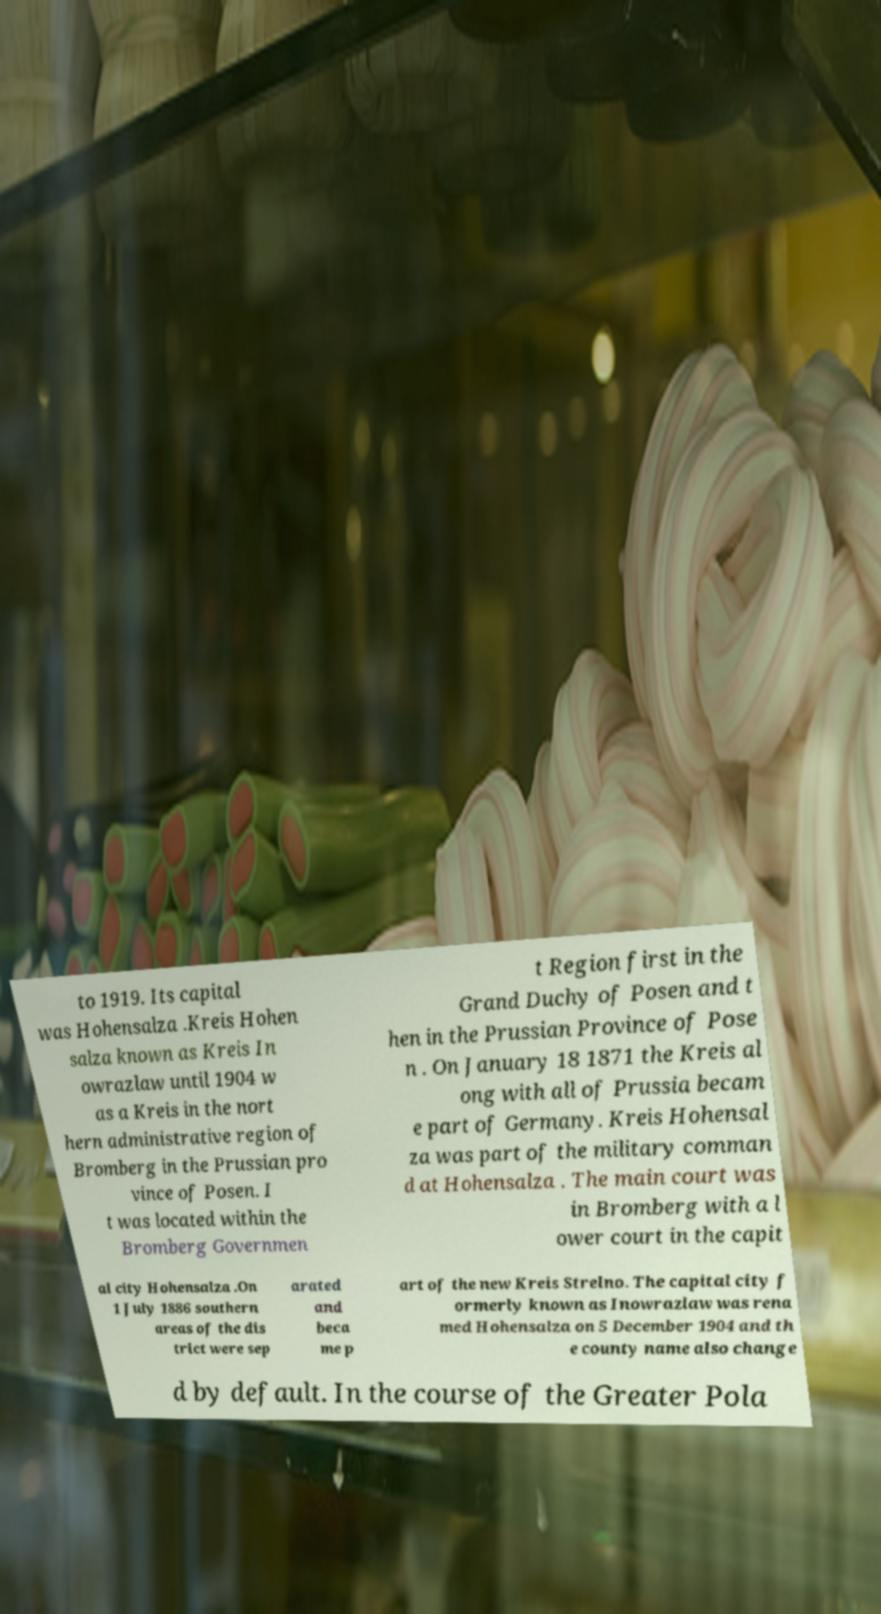I need the written content from this picture converted into text. Can you do that? to 1919. Its capital was Hohensalza .Kreis Hohen salza known as Kreis In owrazlaw until 1904 w as a Kreis in the nort hern administrative region of Bromberg in the Prussian pro vince of Posen. I t was located within the Bromberg Governmen t Region first in the Grand Duchy of Posen and t hen in the Prussian Province of Pose n . On January 18 1871 the Kreis al ong with all of Prussia becam e part of Germany. Kreis Hohensal za was part of the military comman d at Hohensalza . The main court was in Bromberg with a l ower court in the capit al city Hohensalza .On 1 July 1886 southern areas of the dis trict were sep arated and beca me p art of the new Kreis Strelno. The capital city f ormerly known as Inowrazlaw was rena med Hohensalza on 5 December 1904 and th e county name also change d by default. In the course of the Greater Pola 